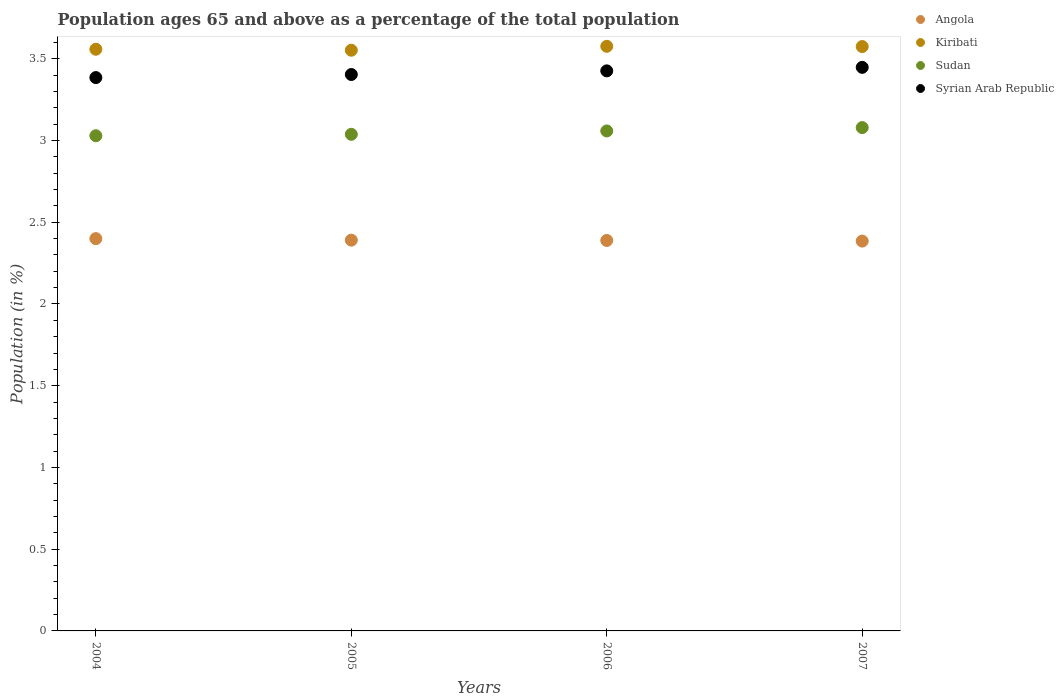How many different coloured dotlines are there?
Your answer should be compact. 4. What is the percentage of the population ages 65 and above in Syrian Arab Republic in 2005?
Offer a terse response. 3.4. Across all years, what is the maximum percentage of the population ages 65 and above in Syrian Arab Republic?
Offer a very short reply. 3.45. Across all years, what is the minimum percentage of the population ages 65 and above in Angola?
Make the answer very short. 2.38. In which year was the percentage of the population ages 65 and above in Angola maximum?
Provide a succinct answer. 2004. What is the total percentage of the population ages 65 and above in Kiribati in the graph?
Offer a very short reply. 14.26. What is the difference between the percentage of the population ages 65 and above in Kiribati in 2004 and that in 2007?
Provide a succinct answer. -0.02. What is the difference between the percentage of the population ages 65 and above in Sudan in 2006 and the percentage of the population ages 65 and above in Syrian Arab Republic in 2005?
Provide a succinct answer. -0.35. What is the average percentage of the population ages 65 and above in Syrian Arab Republic per year?
Your answer should be compact. 3.42. In the year 2006, what is the difference between the percentage of the population ages 65 and above in Sudan and percentage of the population ages 65 and above in Syrian Arab Republic?
Provide a succinct answer. -0.37. What is the ratio of the percentage of the population ages 65 and above in Angola in 2005 to that in 2006?
Provide a short and direct response. 1. What is the difference between the highest and the second highest percentage of the population ages 65 and above in Angola?
Provide a short and direct response. 0.01. What is the difference between the highest and the lowest percentage of the population ages 65 and above in Sudan?
Your response must be concise. 0.05. Is the sum of the percentage of the population ages 65 and above in Sudan in 2004 and 2007 greater than the maximum percentage of the population ages 65 and above in Syrian Arab Republic across all years?
Your answer should be compact. Yes. Is it the case that in every year, the sum of the percentage of the population ages 65 and above in Sudan and percentage of the population ages 65 and above in Angola  is greater than the percentage of the population ages 65 and above in Kiribati?
Your answer should be compact. Yes. Does the percentage of the population ages 65 and above in Angola monotonically increase over the years?
Provide a succinct answer. No. Is the percentage of the population ages 65 and above in Kiribati strictly greater than the percentage of the population ages 65 and above in Syrian Arab Republic over the years?
Provide a succinct answer. Yes. Is the percentage of the population ages 65 and above in Kiribati strictly less than the percentage of the population ages 65 and above in Sudan over the years?
Give a very brief answer. No. How many dotlines are there?
Provide a succinct answer. 4. What is the difference between two consecutive major ticks on the Y-axis?
Offer a terse response. 0.5. Does the graph contain any zero values?
Your answer should be compact. No. Does the graph contain grids?
Keep it short and to the point. No. Where does the legend appear in the graph?
Provide a succinct answer. Top right. How are the legend labels stacked?
Your answer should be compact. Vertical. What is the title of the graph?
Your answer should be very brief. Population ages 65 and above as a percentage of the total population. What is the label or title of the X-axis?
Give a very brief answer. Years. What is the Population (in %) in Angola in 2004?
Provide a succinct answer. 2.4. What is the Population (in %) of Kiribati in 2004?
Provide a short and direct response. 3.56. What is the Population (in %) in Sudan in 2004?
Ensure brevity in your answer.  3.03. What is the Population (in %) of Syrian Arab Republic in 2004?
Your answer should be very brief. 3.39. What is the Population (in %) in Angola in 2005?
Offer a very short reply. 2.39. What is the Population (in %) in Kiribati in 2005?
Offer a very short reply. 3.55. What is the Population (in %) in Sudan in 2005?
Keep it short and to the point. 3.04. What is the Population (in %) of Syrian Arab Republic in 2005?
Your response must be concise. 3.4. What is the Population (in %) in Angola in 2006?
Offer a very short reply. 2.39. What is the Population (in %) of Kiribati in 2006?
Keep it short and to the point. 3.58. What is the Population (in %) of Sudan in 2006?
Ensure brevity in your answer.  3.06. What is the Population (in %) in Syrian Arab Republic in 2006?
Give a very brief answer. 3.43. What is the Population (in %) of Angola in 2007?
Your response must be concise. 2.38. What is the Population (in %) in Kiribati in 2007?
Keep it short and to the point. 3.57. What is the Population (in %) in Sudan in 2007?
Your answer should be very brief. 3.08. What is the Population (in %) in Syrian Arab Republic in 2007?
Provide a succinct answer. 3.45. Across all years, what is the maximum Population (in %) in Angola?
Offer a very short reply. 2.4. Across all years, what is the maximum Population (in %) of Kiribati?
Offer a very short reply. 3.58. Across all years, what is the maximum Population (in %) of Sudan?
Your answer should be compact. 3.08. Across all years, what is the maximum Population (in %) in Syrian Arab Republic?
Provide a succinct answer. 3.45. Across all years, what is the minimum Population (in %) in Angola?
Your answer should be very brief. 2.38. Across all years, what is the minimum Population (in %) of Kiribati?
Keep it short and to the point. 3.55. Across all years, what is the minimum Population (in %) of Sudan?
Your answer should be very brief. 3.03. Across all years, what is the minimum Population (in %) in Syrian Arab Republic?
Make the answer very short. 3.39. What is the total Population (in %) of Angola in the graph?
Offer a terse response. 9.56. What is the total Population (in %) in Kiribati in the graph?
Ensure brevity in your answer.  14.26. What is the total Population (in %) of Sudan in the graph?
Ensure brevity in your answer.  12.21. What is the total Population (in %) of Syrian Arab Republic in the graph?
Keep it short and to the point. 13.66. What is the difference between the Population (in %) in Angola in 2004 and that in 2005?
Provide a short and direct response. 0.01. What is the difference between the Population (in %) in Kiribati in 2004 and that in 2005?
Give a very brief answer. 0.01. What is the difference between the Population (in %) of Sudan in 2004 and that in 2005?
Offer a very short reply. -0.01. What is the difference between the Population (in %) in Syrian Arab Republic in 2004 and that in 2005?
Offer a very short reply. -0.02. What is the difference between the Population (in %) of Angola in 2004 and that in 2006?
Ensure brevity in your answer.  0.01. What is the difference between the Population (in %) in Kiribati in 2004 and that in 2006?
Your answer should be very brief. -0.02. What is the difference between the Population (in %) in Sudan in 2004 and that in 2006?
Provide a short and direct response. -0.03. What is the difference between the Population (in %) of Syrian Arab Republic in 2004 and that in 2006?
Your response must be concise. -0.04. What is the difference between the Population (in %) of Angola in 2004 and that in 2007?
Keep it short and to the point. 0.02. What is the difference between the Population (in %) in Kiribati in 2004 and that in 2007?
Offer a terse response. -0.02. What is the difference between the Population (in %) of Sudan in 2004 and that in 2007?
Your answer should be very brief. -0.05. What is the difference between the Population (in %) in Syrian Arab Republic in 2004 and that in 2007?
Offer a very short reply. -0.06. What is the difference between the Population (in %) of Angola in 2005 and that in 2006?
Your answer should be compact. 0. What is the difference between the Population (in %) of Kiribati in 2005 and that in 2006?
Your answer should be compact. -0.02. What is the difference between the Population (in %) of Sudan in 2005 and that in 2006?
Your response must be concise. -0.02. What is the difference between the Population (in %) of Syrian Arab Republic in 2005 and that in 2006?
Ensure brevity in your answer.  -0.02. What is the difference between the Population (in %) of Angola in 2005 and that in 2007?
Give a very brief answer. 0.01. What is the difference between the Population (in %) of Kiribati in 2005 and that in 2007?
Make the answer very short. -0.02. What is the difference between the Population (in %) of Sudan in 2005 and that in 2007?
Offer a very short reply. -0.04. What is the difference between the Population (in %) of Syrian Arab Republic in 2005 and that in 2007?
Offer a very short reply. -0.04. What is the difference between the Population (in %) of Angola in 2006 and that in 2007?
Provide a succinct answer. 0. What is the difference between the Population (in %) in Kiribati in 2006 and that in 2007?
Keep it short and to the point. 0. What is the difference between the Population (in %) in Sudan in 2006 and that in 2007?
Ensure brevity in your answer.  -0.02. What is the difference between the Population (in %) in Syrian Arab Republic in 2006 and that in 2007?
Offer a terse response. -0.02. What is the difference between the Population (in %) of Angola in 2004 and the Population (in %) of Kiribati in 2005?
Your response must be concise. -1.15. What is the difference between the Population (in %) in Angola in 2004 and the Population (in %) in Sudan in 2005?
Provide a succinct answer. -0.64. What is the difference between the Population (in %) in Angola in 2004 and the Population (in %) in Syrian Arab Republic in 2005?
Give a very brief answer. -1. What is the difference between the Population (in %) of Kiribati in 2004 and the Population (in %) of Sudan in 2005?
Provide a short and direct response. 0.52. What is the difference between the Population (in %) of Kiribati in 2004 and the Population (in %) of Syrian Arab Republic in 2005?
Your answer should be very brief. 0.15. What is the difference between the Population (in %) of Sudan in 2004 and the Population (in %) of Syrian Arab Republic in 2005?
Your response must be concise. -0.37. What is the difference between the Population (in %) of Angola in 2004 and the Population (in %) of Kiribati in 2006?
Make the answer very short. -1.18. What is the difference between the Population (in %) of Angola in 2004 and the Population (in %) of Sudan in 2006?
Offer a terse response. -0.66. What is the difference between the Population (in %) in Angola in 2004 and the Population (in %) in Syrian Arab Republic in 2006?
Offer a terse response. -1.03. What is the difference between the Population (in %) of Kiribati in 2004 and the Population (in %) of Sudan in 2006?
Offer a terse response. 0.5. What is the difference between the Population (in %) in Kiribati in 2004 and the Population (in %) in Syrian Arab Republic in 2006?
Your answer should be very brief. 0.13. What is the difference between the Population (in %) of Sudan in 2004 and the Population (in %) of Syrian Arab Republic in 2006?
Make the answer very short. -0.4. What is the difference between the Population (in %) of Angola in 2004 and the Population (in %) of Kiribati in 2007?
Offer a terse response. -1.17. What is the difference between the Population (in %) in Angola in 2004 and the Population (in %) in Sudan in 2007?
Your answer should be very brief. -0.68. What is the difference between the Population (in %) of Angola in 2004 and the Population (in %) of Syrian Arab Republic in 2007?
Your answer should be compact. -1.05. What is the difference between the Population (in %) in Kiribati in 2004 and the Population (in %) in Sudan in 2007?
Your answer should be compact. 0.48. What is the difference between the Population (in %) in Kiribati in 2004 and the Population (in %) in Syrian Arab Republic in 2007?
Give a very brief answer. 0.11. What is the difference between the Population (in %) of Sudan in 2004 and the Population (in %) of Syrian Arab Republic in 2007?
Ensure brevity in your answer.  -0.42. What is the difference between the Population (in %) of Angola in 2005 and the Population (in %) of Kiribati in 2006?
Offer a terse response. -1.19. What is the difference between the Population (in %) of Angola in 2005 and the Population (in %) of Sudan in 2006?
Provide a short and direct response. -0.67. What is the difference between the Population (in %) of Angola in 2005 and the Population (in %) of Syrian Arab Republic in 2006?
Offer a terse response. -1.04. What is the difference between the Population (in %) of Kiribati in 2005 and the Population (in %) of Sudan in 2006?
Provide a short and direct response. 0.49. What is the difference between the Population (in %) of Kiribati in 2005 and the Population (in %) of Syrian Arab Republic in 2006?
Offer a very short reply. 0.13. What is the difference between the Population (in %) of Sudan in 2005 and the Population (in %) of Syrian Arab Republic in 2006?
Keep it short and to the point. -0.39. What is the difference between the Population (in %) in Angola in 2005 and the Population (in %) in Kiribati in 2007?
Keep it short and to the point. -1.18. What is the difference between the Population (in %) of Angola in 2005 and the Population (in %) of Sudan in 2007?
Make the answer very short. -0.69. What is the difference between the Population (in %) of Angola in 2005 and the Population (in %) of Syrian Arab Republic in 2007?
Give a very brief answer. -1.06. What is the difference between the Population (in %) of Kiribati in 2005 and the Population (in %) of Sudan in 2007?
Ensure brevity in your answer.  0.47. What is the difference between the Population (in %) of Kiribati in 2005 and the Population (in %) of Syrian Arab Republic in 2007?
Your answer should be very brief. 0.1. What is the difference between the Population (in %) of Sudan in 2005 and the Population (in %) of Syrian Arab Republic in 2007?
Provide a succinct answer. -0.41. What is the difference between the Population (in %) of Angola in 2006 and the Population (in %) of Kiribati in 2007?
Your answer should be compact. -1.19. What is the difference between the Population (in %) of Angola in 2006 and the Population (in %) of Sudan in 2007?
Offer a very short reply. -0.69. What is the difference between the Population (in %) of Angola in 2006 and the Population (in %) of Syrian Arab Republic in 2007?
Offer a terse response. -1.06. What is the difference between the Population (in %) of Kiribati in 2006 and the Population (in %) of Sudan in 2007?
Make the answer very short. 0.5. What is the difference between the Population (in %) in Kiribati in 2006 and the Population (in %) in Syrian Arab Republic in 2007?
Offer a terse response. 0.13. What is the difference between the Population (in %) in Sudan in 2006 and the Population (in %) in Syrian Arab Republic in 2007?
Offer a terse response. -0.39. What is the average Population (in %) in Angola per year?
Provide a succinct answer. 2.39. What is the average Population (in %) in Kiribati per year?
Offer a terse response. 3.57. What is the average Population (in %) of Sudan per year?
Keep it short and to the point. 3.05. What is the average Population (in %) in Syrian Arab Republic per year?
Keep it short and to the point. 3.42. In the year 2004, what is the difference between the Population (in %) of Angola and Population (in %) of Kiribati?
Provide a succinct answer. -1.16. In the year 2004, what is the difference between the Population (in %) of Angola and Population (in %) of Sudan?
Offer a very short reply. -0.63. In the year 2004, what is the difference between the Population (in %) in Angola and Population (in %) in Syrian Arab Republic?
Provide a short and direct response. -0.99. In the year 2004, what is the difference between the Population (in %) of Kiribati and Population (in %) of Sudan?
Your response must be concise. 0.53. In the year 2004, what is the difference between the Population (in %) of Kiribati and Population (in %) of Syrian Arab Republic?
Keep it short and to the point. 0.17. In the year 2004, what is the difference between the Population (in %) in Sudan and Population (in %) in Syrian Arab Republic?
Offer a terse response. -0.36. In the year 2005, what is the difference between the Population (in %) in Angola and Population (in %) in Kiribati?
Your answer should be compact. -1.16. In the year 2005, what is the difference between the Population (in %) of Angola and Population (in %) of Sudan?
Your answer should be very brief. -0.65. In the year 2005, what is the difference between the Population (in %) of Angola and Population (in %) of Syrian Arab Republic?
Give a very brief answer. -1.01. In the year 2005, what is the difference between the Population (in %) of Kiribati and Population (in %) of Sudan?
Your answer should be very brief. 0.51. In the year 2005, what is the difference between the Population (in %) of Kiribati and Population (in %) of Syrian Arab Republic?
Offer a terse response. 0.15. In the year 2005, what is the difference between the Population (in %) of Sudan and Population (in %) of Syrian Arab Republic?
Provide a short and direct response. -0.37. In the year 2006, what is the difference between the Population (in %) of Angola and Population (in %) of Kiribati?
Offer a terse response. -1.19. In the year 2006, what is the difference between the Population (in %) in Angola and Population (in %) in Sudan?
Your response must be concise. -0.67. In the year 2006, what is the difference between the Population (in %) of Angola and Population (in %) of Syrian Arab Republic?
Provide a succinct answer. -1.04. In the year 2006, what is the difference between the Population (in %) in Kiribati and Population (in %) in Sudan?
Your answer should be very brief. 0.52. In the year 2006, what is the difference between the Population (in %) of Kiribati and Population (in %) of Syrian Arab Republic?
Ensure brevity in your answer.  0.15. In the year 2006, what is the difference between the Population (in %) in Sudan and Population (in %) in Syrian Arab Republic?
Your answer should be very brief. -0.37. In the year 2007, what is the difference between the Population (in %) in Angola and Population (in %) in Kiribati?
Your answer should be compact. -1.19. In the year 2007, what is the difference between the Population (in %) in Angola and Population (in %) in Sudan?
Offer a terse response. -0.69. In the year 2007, what is the difference between the Population (in %) in Angola and Population (in %) in Syrian Arab Republic?
Offer a terse response. -1.06. In the year 2007, what is the difference between the Population (in %) in Kiribati and Population (in %) in Sudan?
Make the answer very short. 0.5. In the year 2007, what is the difference between the Population (in %) in Kiribati and Population (in %) in Syrian Arab Republic?
Your answer should be compact. 0.13. In the year 2007, what is the difference between the Population (in %) in Sudan and Population (in %) in Syrian Arab Republic?
Offer a very short reply. -0.37. What is the ratio of the Population (in %) of Angola in 2004 to that in 2005?
Provide a short and direct response. 1. What is the ratio of the Population (in %) of Syrian Arab Republic in 2004 to that in 2005?
Your response must be concise. 0.99. What is the ratio of the Population (in %) of Angola in 2004 to that in 2006?
Ensure brevity in your answer.  1. What is the ratio of the Population (in %) of Syrian Arab Republic in 2004 to that in 2006?
Your answer should be compact. 0.99. What is the ratio of the Population (in %) in Angola in 2004 to that in 2007?
Make the answer very short. 1.01. What is the ratio of the Population (in %) of Sudan in 2004 to that in 2007?
Your answer should be very brief. 0.98. What is the ratio of the Population (in %) of Syrian Arab Republic in 2004 to that in 2007?
Keep it short and to the point. 0.98. What is the ratio of the Population (in %) of Sudan in 2005 to that in 2006?
Offer a very short reply. 0.99. What is the ratio of the Population (in %) of Syrian Arab Republic in 2005 to that in 2006?
Offer a terse response. 0.99. What is the ratio of the Population (in %) of Kiribati in 2005 to that in 2007?
Ensure brevity in your answer.  0.99. What is the ratio of the Population (in %) of Sudan in 2005 to that in 2007?
Offer a very short reply. 0.99. What is the ratio of the Population (in %) in Syrian Arab Republic in 2005 to that in 2007?
Offer a terse response. 0.99. What is the ratio of the Population (in %) of Kiribati in 2006 to that in 2007?
Provide a short and direct response. 1. What is the ratio of the Population (in %) of Sudan in 2006 to that in 2007?
Offer a very short reply. 0.99. What is the ratio of the Population (in %) of Syrian Arab Republic in 2006 to that in 2007?
Your response must be concise. 0.99. What is the difference between the highest and the second highest Population (in %) of Angola?
Your answer should be compact. 0.01. What is the difference between the highest and the second highest Population (in %) in Kiribati?
Your answer should be very brief. 0. What is the difference between the highest and the second highest Population (in %) of Sudan?
Give a very brief answer. 0.02. What is the difference between the highest and the second highest Population (in %) of Syrian Arab Republic?
Make the answer very short. 0.02. What is the difference between the highest and the lowest Population (in %) of Angola?
Offer a terse response. 0.02. What is the difference between the highest and the lowest Population (in %) in Kiribati?
Your answer should be very brief. 0.02. What is the difference between the highest and the lowest Population (in %) in Sudan?
Offer a very short reply. 0.05. What is the difference between the highest and the lowest Population (in %) of Syrian Arab Republic?
Provide a short and direct response. 0.06. 